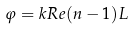Convert formula to latex. <formula><loc_0><loc_0><loc_500><loc_500>\varphi = k R e ( n - 1 ) L</formula> 